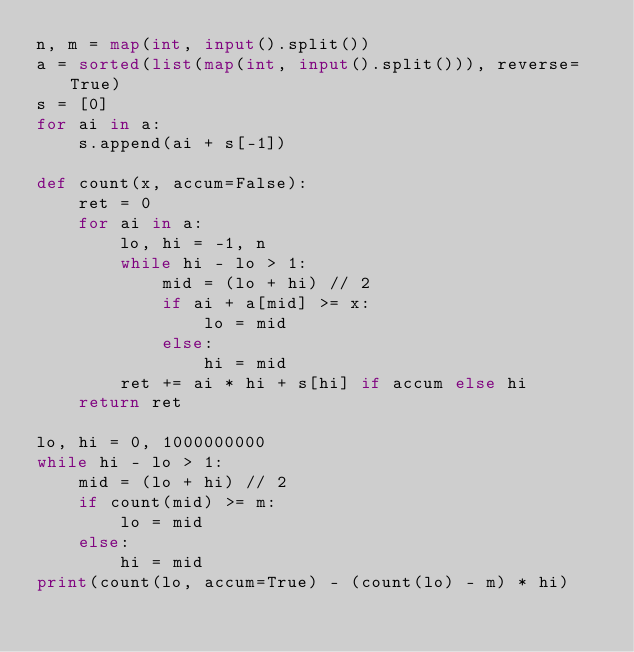<code> <loc_0><loc_0><loc_500><loc_500><_Python_>n, m = map(int, input().split())
a = sorted(list(map(int, input().split())), reverse=True)
s = [0]
for ai in a:
    s.append(ai + s[-1])

def count(x, accum=False):
    ret = 0
    for ai in a:
        lo, hi = -1, n
        while hi - lo > 1:
            mid = (lo + hi) // 2
            if ai + a[mid] >= x:
                lo = mid
            else:
                hi = mid
        ret += ai * hi + s[hi] if accum else hi
    return ret

lo, hi = 0, 1000000000
while hi - lo > 1:
    mid = (lo + hi) // 2
    if count(mid) >= m:
        lo = mid
    else:
        hi = mid
print(count(lo, accum=True) - (count(lo) - m) * hi)</code> 